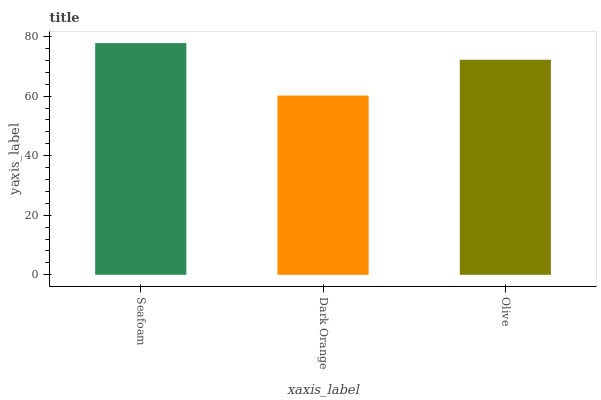Is Dark Orange the minimum?
Answer yes or no. Yes. Is Seafoam the maximum?
Answer yes or no. Yes. Is Olive the minimum?
Answer yes or no. No. Is Olive the maximum?
Answer yes or no. No. Is Olive greater than Dark Orange?
Answer yes or no. Yes. Is Dark Orange less than Olive?
Answer yes or no. Yes. Is Dark Orange greater than Olive?
Answer yes or no. No. Is Olive less than Dark Orange?
Answer yes or no. No. Is Olive the high median?
Answer yes or no. Yes. Is Olive the low median?
Answer yes or no. Yes. Is Seafoam the high median?
Answer yes or no. No. Is Dark Orange the low median?
Answer yes or no. No. 